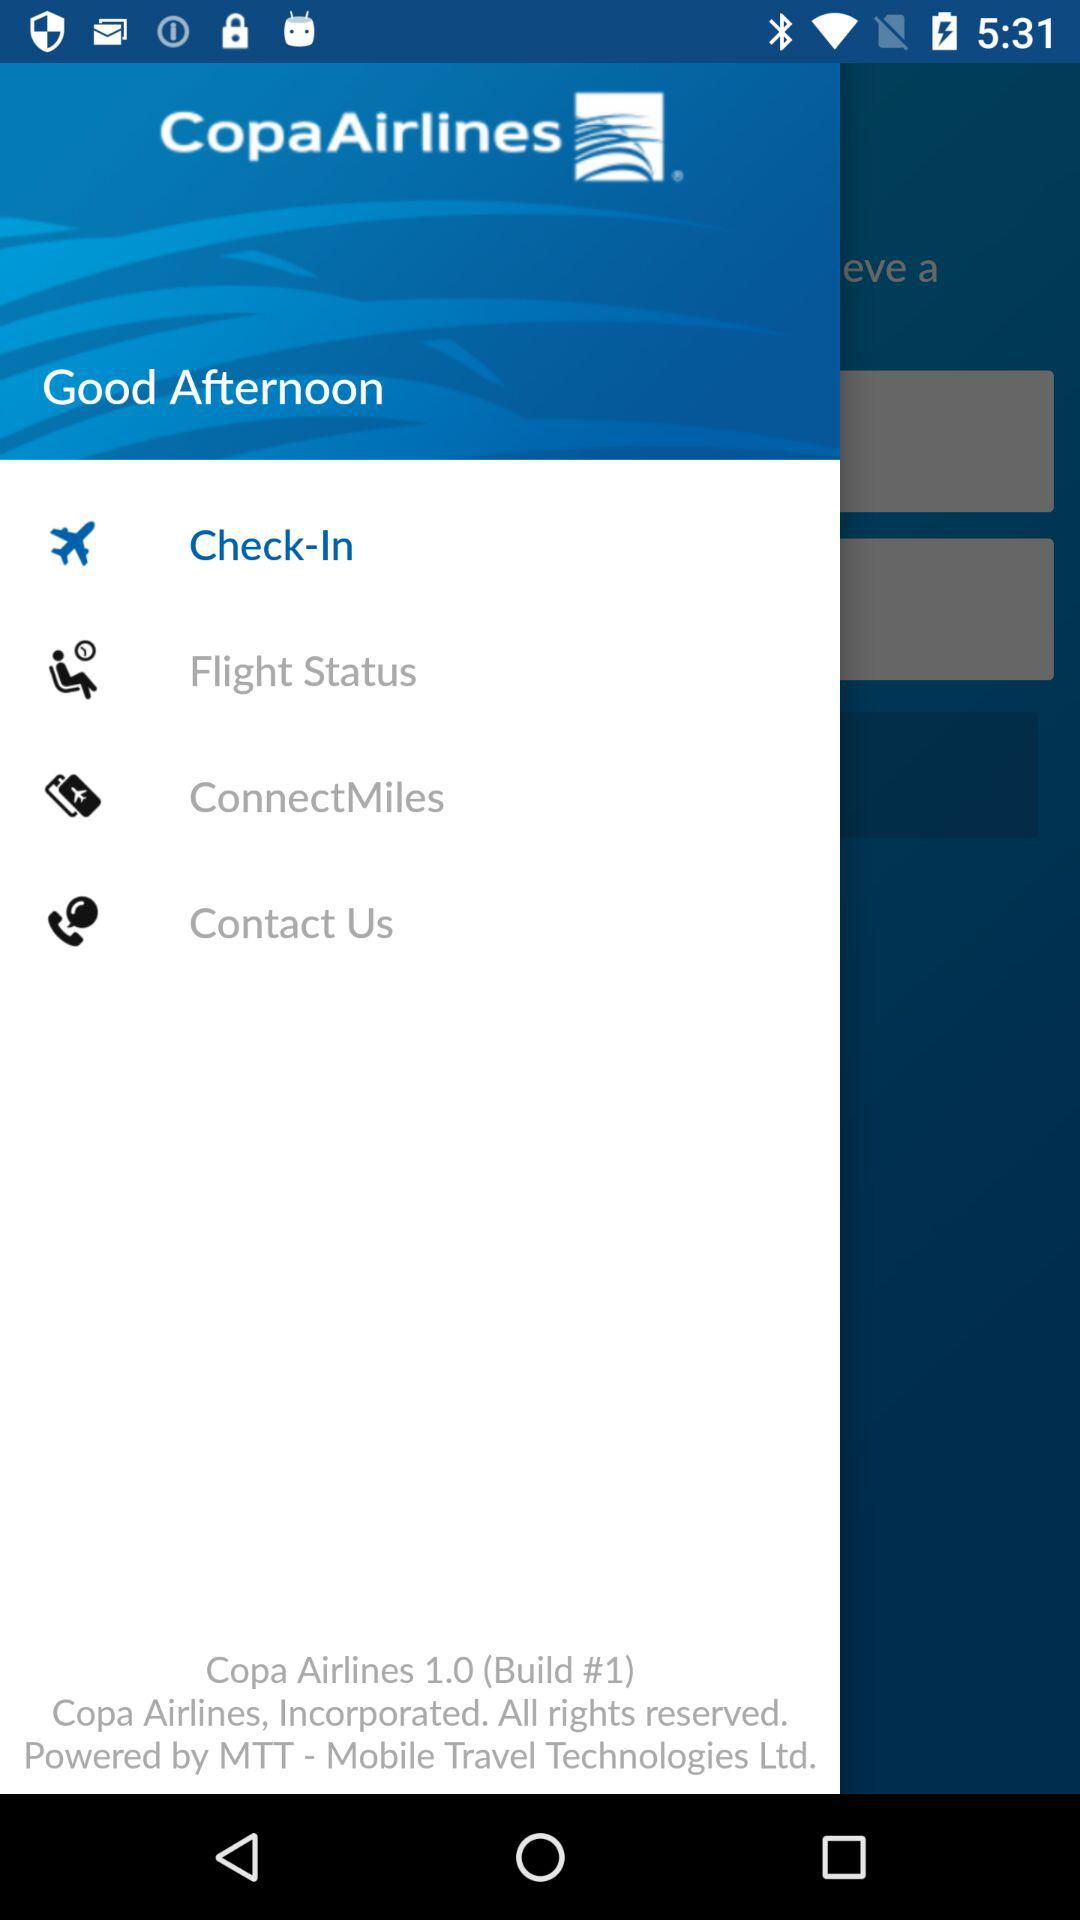What is the application name? The application name is "CopaAirlines". 